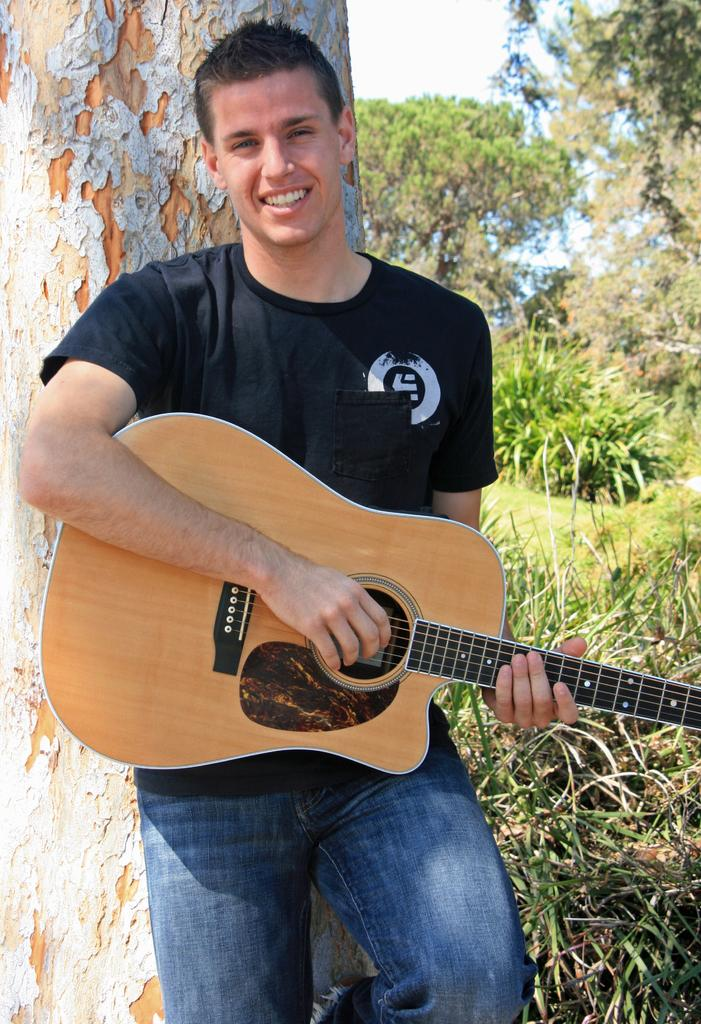What is the man in the center of the image doing? The man is standing in the center of the image and holding a guitar. What is the man's facial expression in the image? The man is smiling in the image. What can be seen in the background of the image? There is a tree, plants, grass, and the sky visible in the background of the image. What type of wood is the wren perched on in the image? There is no wren present in the image, so it is not possible to determine what type of wood it might be perched on. 